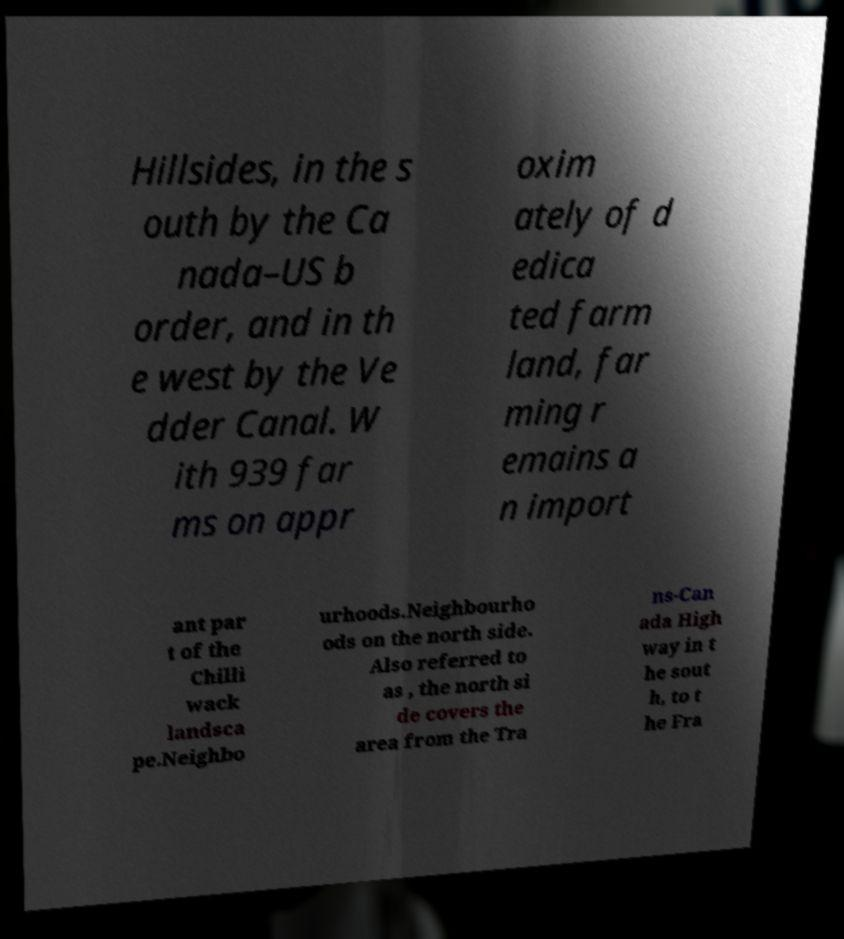What messages or text are displayed in this image? I need them in a readable, typed format. Hillsides, in the s outh by the Ca nada–US b order, and in th e west by the Ve dder Canal. W ith 939 far ms on appr oxim ately of d edica ted farm land, far ming r emains a n import ant par t of the Chilli wack landsca pe.Neighbo urhoods.Neighbourho ods on the north side. Also referred to as , the north si de covers the area from the Tra ns-Can ada High way in t he sout h, to t he Fra 